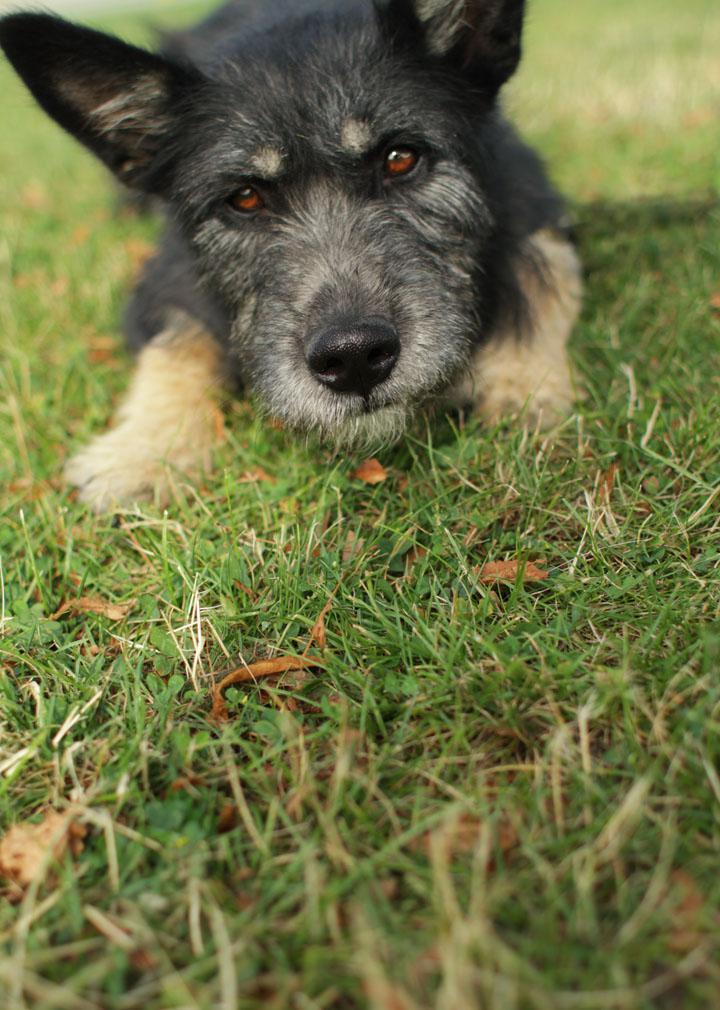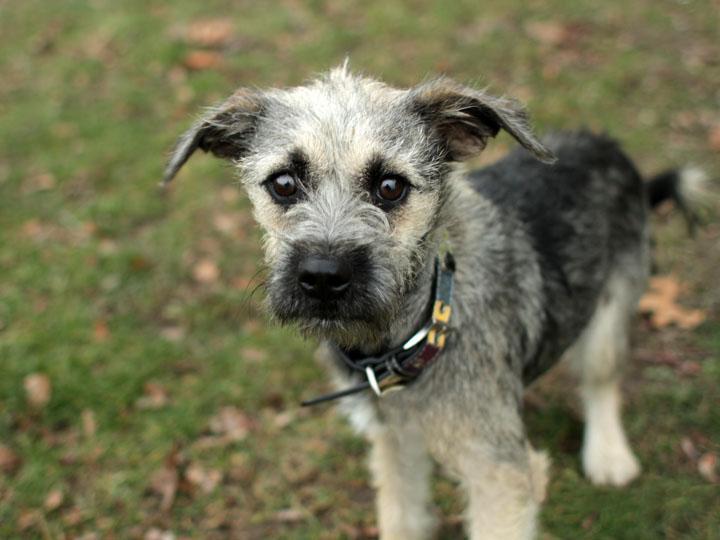The first image is the image on the left, the second image is the image on the right. For the images shown, is this caption "At least four dogs are visible." true? Answer yes or no. No. The first image is the image on the left, the second image is the image on the right. Analyze the images presented: Is the assertion "A puppy is standing up, and an adult dog is lying down." valid? Answer yes or no. Yes. 